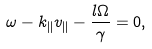<formula> <loc_0><loc_0><loc_500><loc_500>\omega - k _ { \| } v _ { \| } - \frac { l \Omega } { \gamma } = 0 ,</formula> 